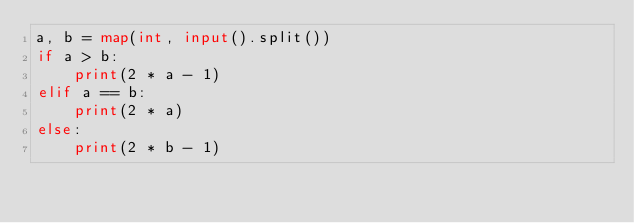<code> <loc_0><loc_0><loc_500><loc_500><_Python_>a, b = map(int, input().split())
if a > b:
    print(2 * a - 1)
elif a == b:
    print(2 * a)
else:
    print(2 * b - 1)</code> 